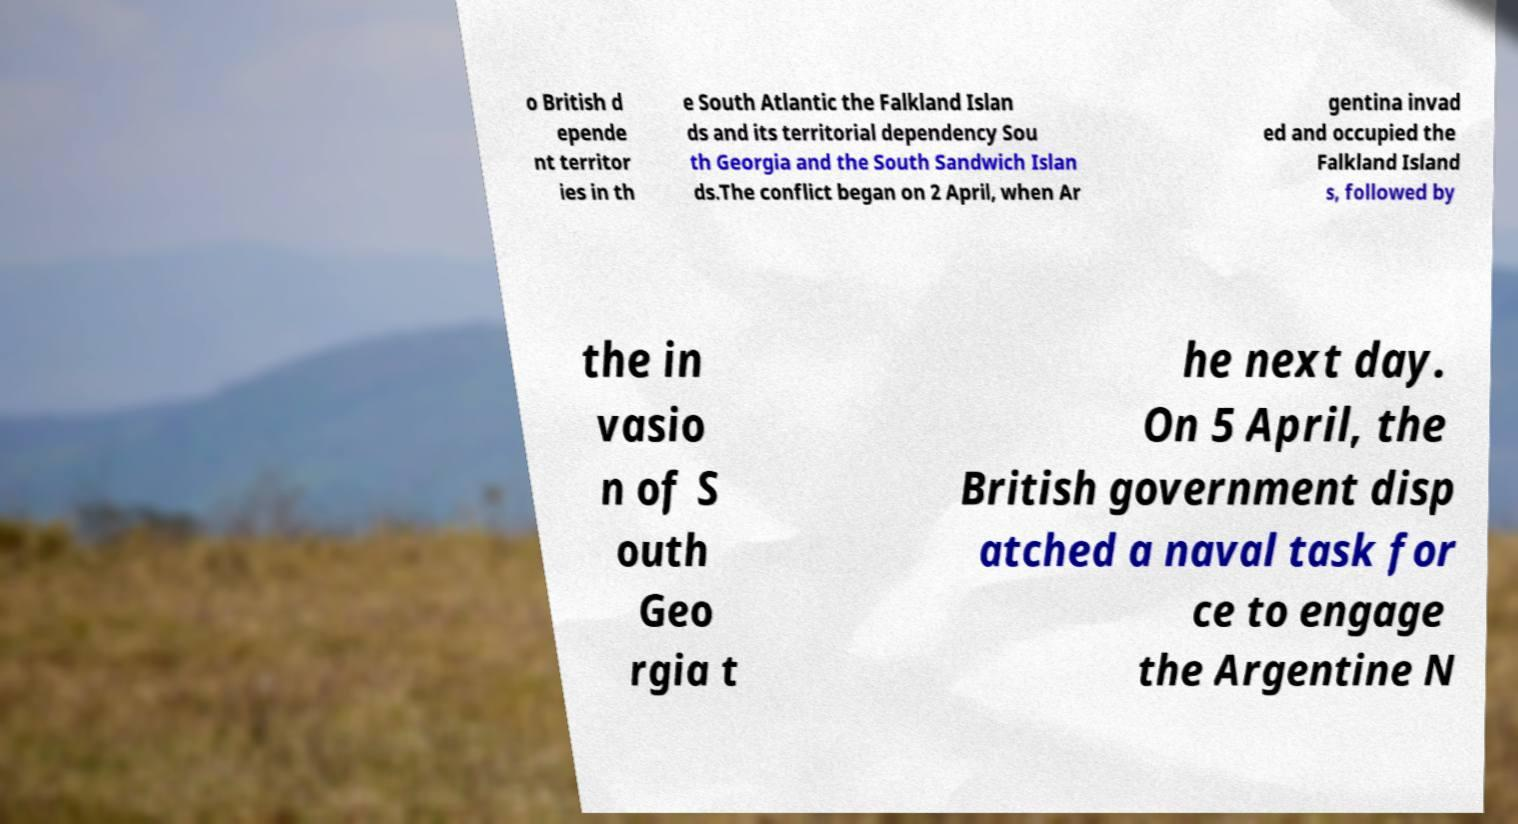Could you extract and type out the text from this image? o British d epende nt territor ies in th e South Atlantic the Falkland Islan ds and its territorial dependency Sou th Georgia and the South Sandwich Islan ds.The conflict began on 2 April, when Ar gentina invad ed and occupied the Falkland Island s, followed by the in vasio n of S outh Geo rgia t he next day. On 5 April, the British government disp atched a naval task for ce to engage the Argentine N 